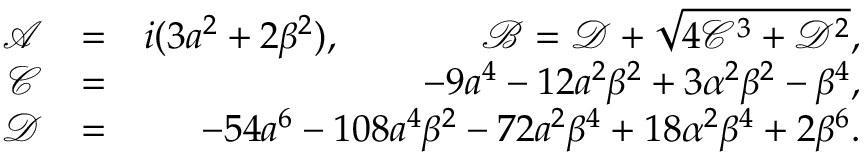Convert formula to latex. <formula><loc_0><loc_0><loc_500><loc_500>\begin{array} { r l r } { \mathcal { A } } & { = } & { i ( 3 a ^ { 2 } + 2 \beta ^ { 2 } ) , \mathcal { B } = \mathcal { D } + \sqrt { 4 \mathcal { C } ^ { 3 } + \mathcal { D } ^ { 2 } } , } \\ { \mathcal { C } } & { = } & { - 9 a ^ { 4 } - 1 2 a ^ { 2 } \beta ^ { 2 } + 3 \alpha ^ { 2 } \beta ^ { 2 } - \beta ^ { 4 } , } \\ { \mathcal { D } } & { = } & { - 5 4 a ^ { 6 } - 1 0 8 a ^ { 4 } \beta ^ { 2 } - 7 2 a ^ { 2 } \beta ^ { 4 } + 1 8 \alpha ^ { 2 } \beta ^ { 4 } + 2 \beta ^ { 6 } . } \end{array}</formula> 